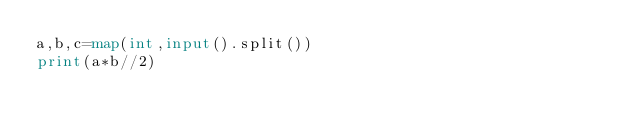Convert code to text. <code><loc_0><loc_0><loc_500><loc_500><_Python_>a,b,c=map(int,input().split())
print(a*b//2)</code> 